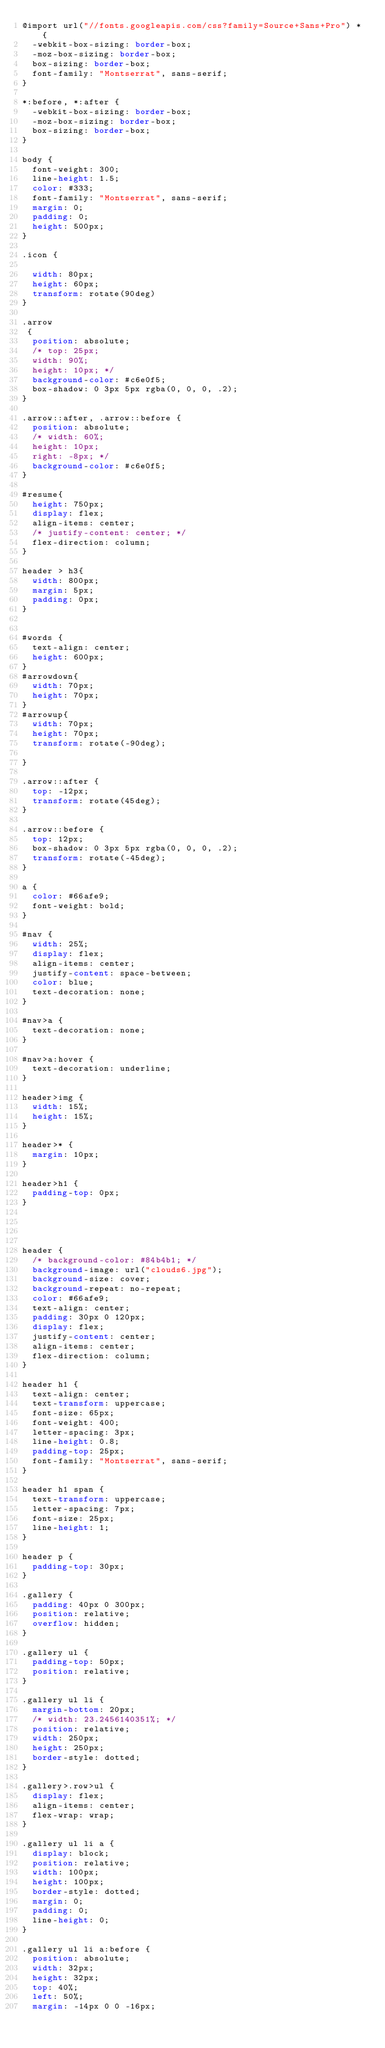Convert code to text. <code><loc_0><loc_0><loc_500><loc_500><_CSS_>@import url("//fonts.googleapis.com/css?family=Source+Sans+Pro") * {
  -webkit-box-sizing: border-box;
  -moz-box-sizing: border-box;
  box-sizing: border-box;
  font-family: "Montserrat", sans-serif;
}

*:before, *:after {
  -webkit-box-sizing: border-box;
  -moz-box-sizing: border-box;
  box-sizing: border-box;
}

body {
  font-weight: 300;
  line-height: 1.5;
  color: #333;
  font-family: "Montserrat", sans-serif;
  margin: 0;
  padding: 0;
  height: 500px;
}

.icon {

  width: 80px;
  height: 60px;
  transform: rotate(90deg)
}

.arrow
 {
  position: absolute;
  /* top: 25px;
  width: 90%;
  height: 10px; */
  background-color: #c6e0f5;
  box-shadow: 0 3px 5px rgba(0, 0, 0, .2);
}

.arrow::after, .arrow::before {
  position: absolute;
  /* width: 60%;
  height: 10px;
  right: -8px; */
  background-color: #c6e0f5;
}

#resume{
  height: 750px;
  display: flex;
  align-items: center;
  /* justify-content: center; */
  flex-direction: column;
}

header > h3{
  width: 800px;
  margin: 5px;
  padding: 0px;
}


#words {
  text-align: center;
  height: 600px;
}
#arrowdown{
  width: 70px;
  height: 70px;
}
#arrowup{
  width: 70px;
  height: 70px;
  transform: rotate(-90deg);

}

.arrow::after {
  top: -12px;
  transform: rotate(45deg);
}

.arrow::before {
  top: 12px;
  box-shadow: 0 3px 5px rgba(0, 0, 0, .2);
  transform: rotate(-45deg);
}

a {
  color: #66afe9;
  font-weight: bold;
}

#nav {
  width: 25%;
  display: flex;
  align-items: center;
  justify-content: space-between;
  color: blue;
  text-decoration: none;
}

#nav>a {
  text-decoration: none;
}

#nav>a:hover {
  text-decoration: underline;
}

header>img {
  width: 15%;
  height: 15%;
}

header>* {
  margin: 10px;
}

header>h1 {
  padding-top: 0px;
}




header {
  /* background-color: #84b4b1; */
  background-image: url("clouds6.jpg");
  background-size: cover;
  background-repeat: no-repeat;
  color: #66afe9;
  text-align: center;
  padding: 30px 0 120px;
  display: flex;
  justify-content: center;
  align-items: center;
  flex-direction: column;
}

header h1 {
  text-align: center;
  text-transform: uppercase;
  font-size: 65px;
  font-weight: 400;
  letter-spacing: 3px;
  line-height: 0.8;
  padding-top: 25px;
  font-family: "Montserrat", sans-serif;
}

header h1 span {
  text-transform: uppercase;
  letter-spacing: 7px;
  font-size: 25px;
  line-height: 1;
}

header p {
  padding-top: 30px;
}

.gallery {
  padding: 40px 0 300px;
  position: relative;
  overflow: hidden;
}

.gallery ul {
  padding-top: 50px;
  position: relative;
}

.gallery ul li {
  margin-bottom: 20px;
  /* width: 23.2456140351%; */
  position: relative;
  width: 250px;
  height: 250px;
  border-style: dotted;
}

.gallery>.row>ul {
  display: flex;
  align-items: center;
  flex-wrap: wrap;
}

.gallery ul li a {
  display: block;
  position: relative;
  width: 100px;
  height: 100px;
  border-style: dotted;
  margin: 0;
  padding: 0;
  line-height: 0;
}

.gallery ul li a:before {
  position: absolute;
  width: 32px;
  height: 32px;
  top: 40%;
  left: 50%;
  margin: -14px 0 0 -16px;</code> 